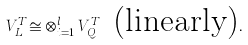<formula> <loc_0><loc_0><loc_500><loc_500>V _ { L } ^ { T } \cong \otimes _ { i = 1 } ^ { l } V _ { Q _ { i } } ^ { T } \, \text { (linearly)} .</formula> 